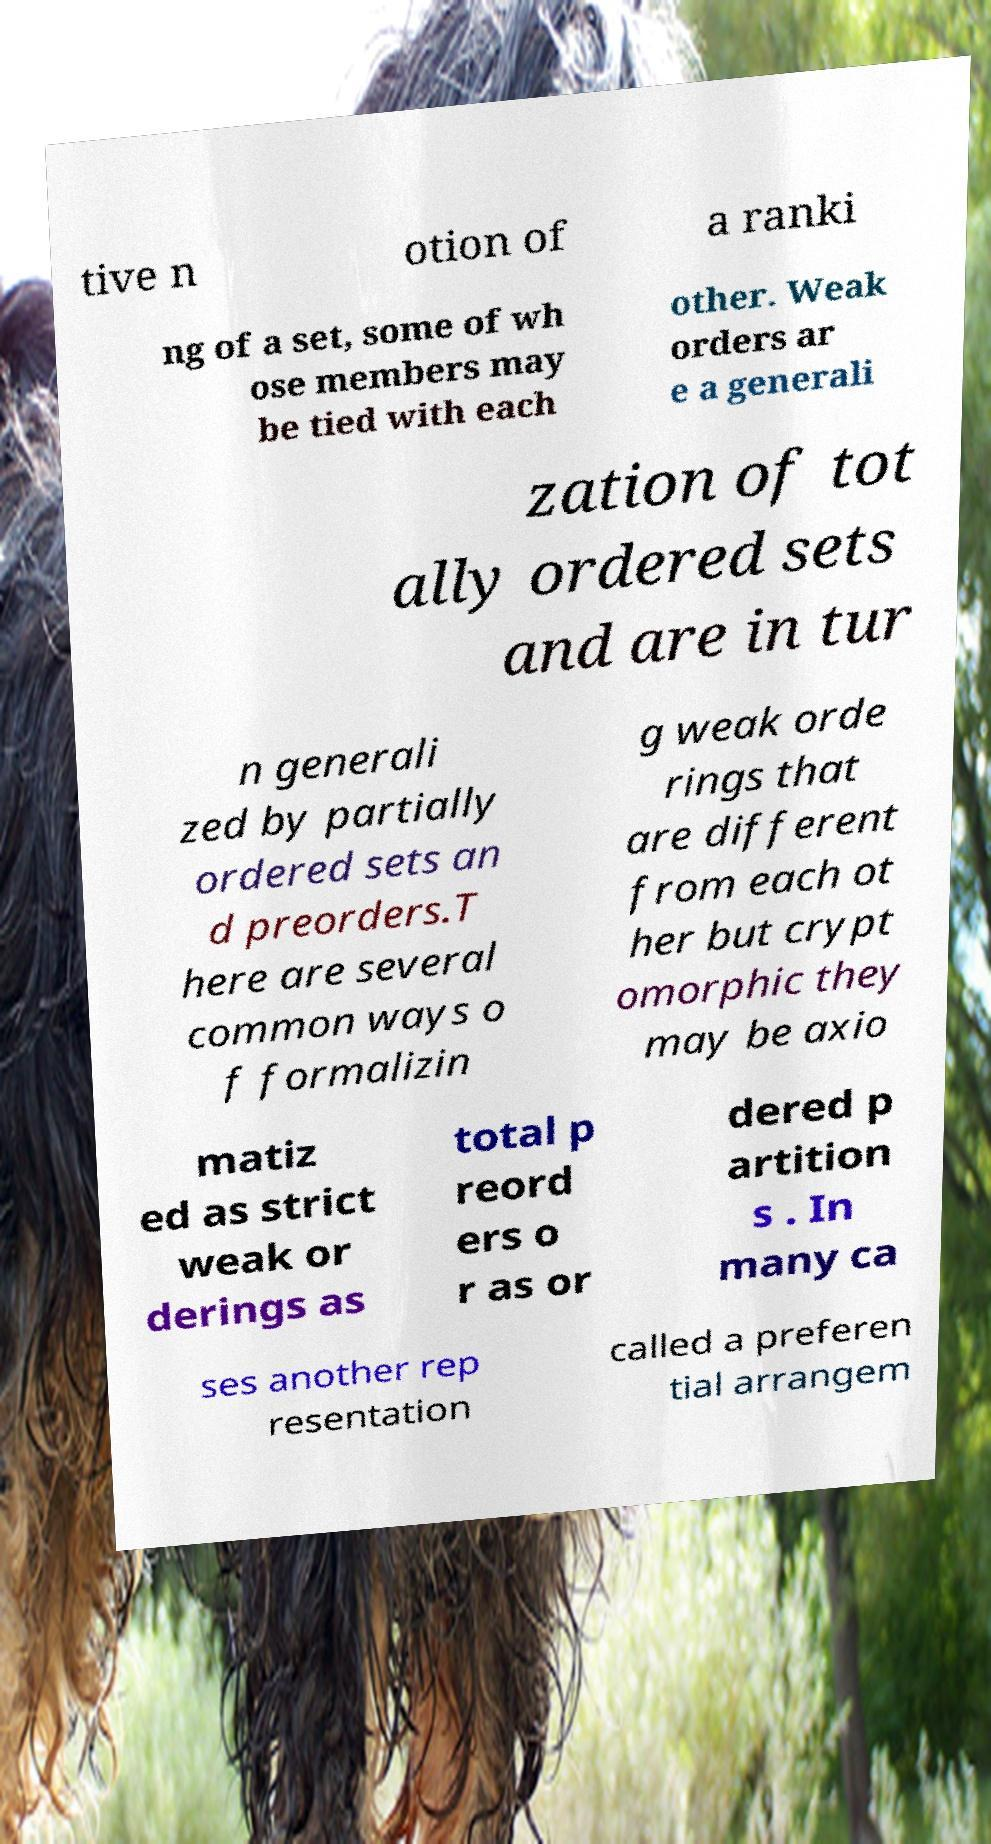Can you read and provide the text displayed in the image?This photo seems to have some interesting text. Can you extract and type it out for me? tive n otion of a ranki ng of a set, some of wh ose members may be tied with each other. Weak orders ar e a generali zation of tot ally ordered sets and are in tur n generali zed by partially ordered sets an d preorders.T here are several common ways o f formalizin g weak orde rings that are different from each ot her but crypt omorphic they may be axio matiz ed as strict weak or derings as total p reord ers o r as or dered p artition s . In many ca ses another rep resentation called a preferen tial arrangem 